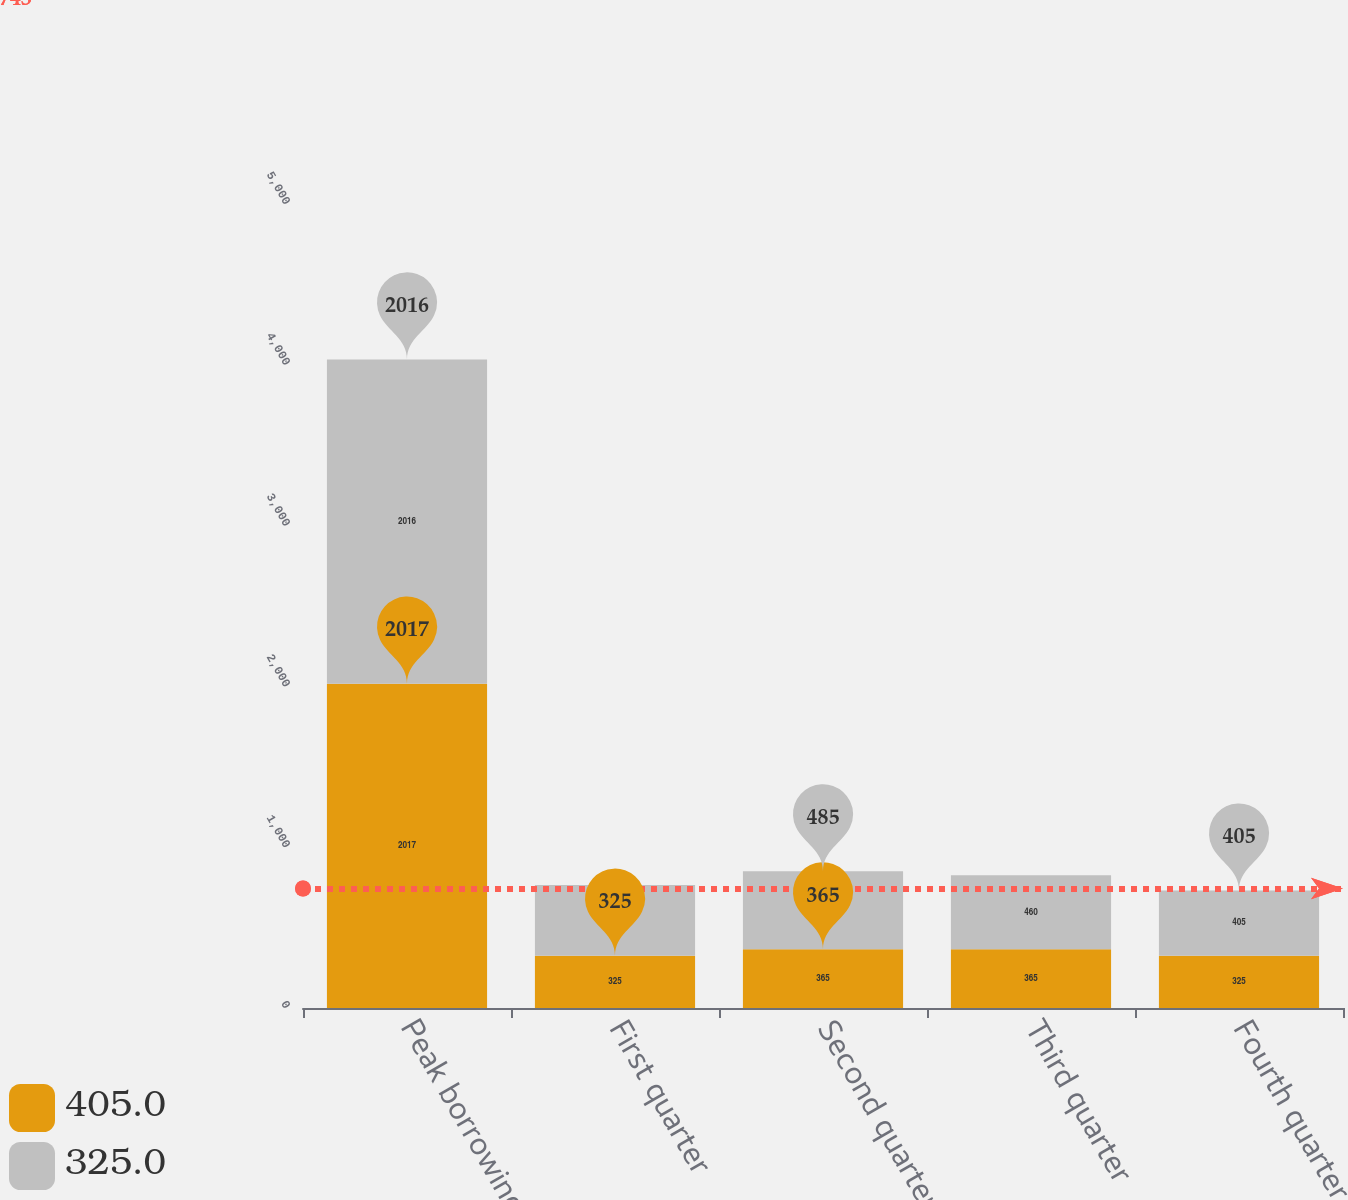Convert chart to OTSL. <chart><loc_0><loc_0><loc_500><loc_500><stacked_bar_chart><ecel><fcel>Peak borrowings<fcel>First quarter<fcel>Second quarter<fcel>Third quarter<fcel>Fourth quarter<nl><fcel>405<fcel>2017<fcel>325<fcel>365<fcel>365<fcel>325<nl><fcel>325<fcel>2016<fcel>440<fcel>485<fcel>460<fcel>405<nl></chart> 